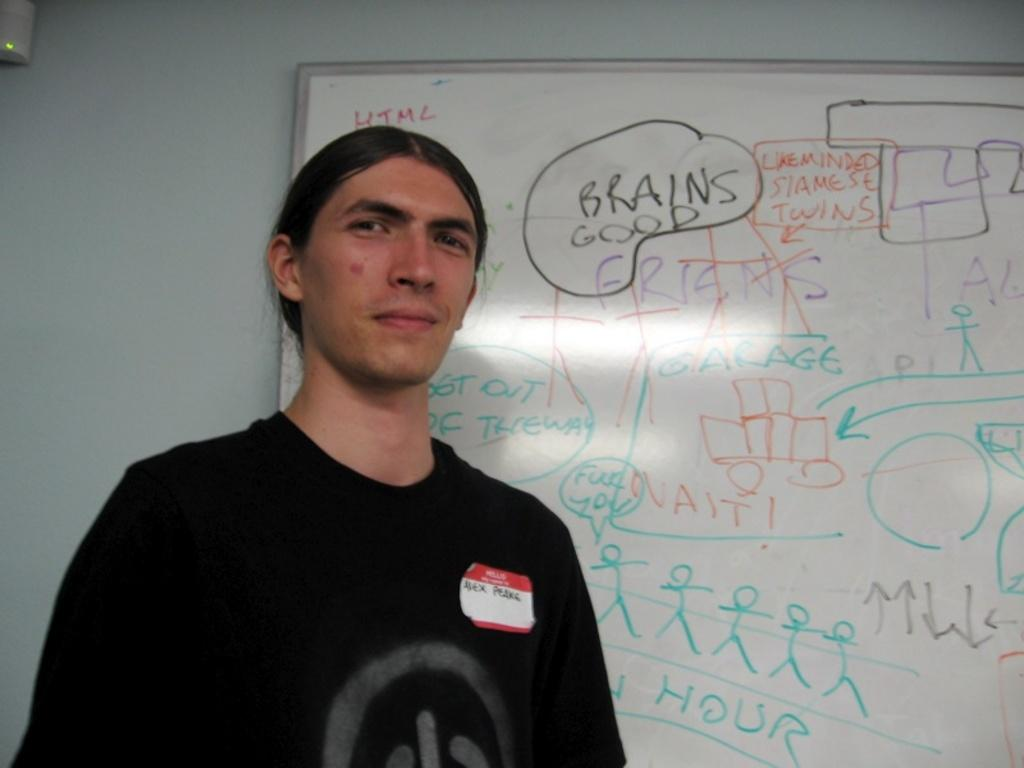<image>
Relay a brief, clear account of the picture shown. A man stands in front of a whiteboard with the words Brains Good above him 